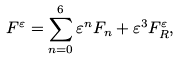<formula> <loc_0><loc_0><loc_500><loc_500>F ^ { \varepsilon } = \sum _ { n = 0 } ^ { 6 } \varepsilon ^ { n } F _ { n } + \varepsilon ^ { 3 } F _ { R } ^ { \varepsilon } ,</formula> 